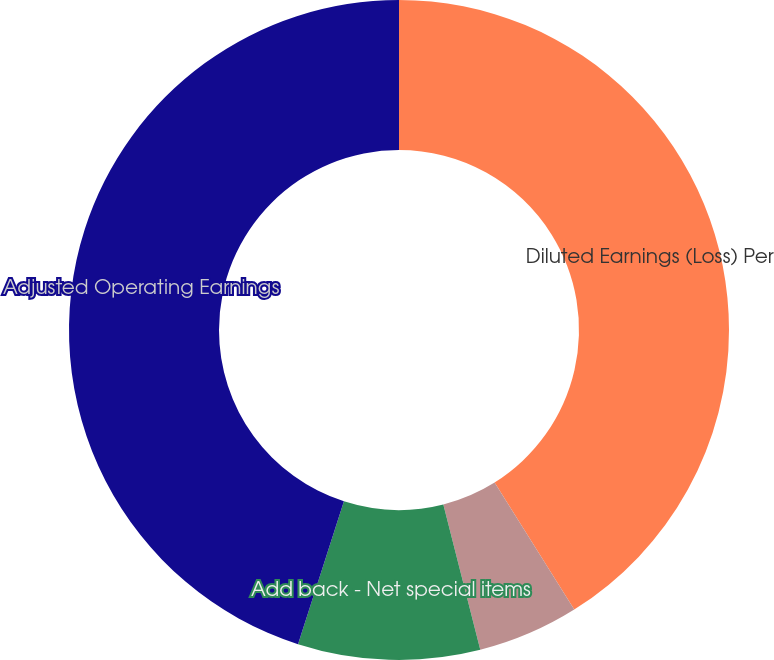Convert chart to OTSL. <chart><loc_0><loc_0><loc_500><loc_500><pie_chart><fcel>Diluted Earnings (Loss) Per<fcel>Add back - Non- operating<fcel>Add back - Net special items<fcel>Adjusted Operating Earnings<nl><fcel>41.09%<fcel>4.95%<fcel>8.91%<fcel>45.05%<nl></chart> 